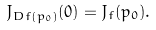<formula> <loc_0><loc_0><loc_500><loc_500>J _ { D f ( p _ { 0 } ) } ( 0 ) = J _ { f } ( p _ { 0 } ) .</formula> 